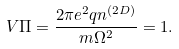<formula> <loc_0><loc_0><loc_500><loc_500>V \Pi = \frac { 2 \pi e ^ { 2 } q n ^ { ( 2 D ) } } { m \Omega ^ { 2 } } = 1 .</formula> 